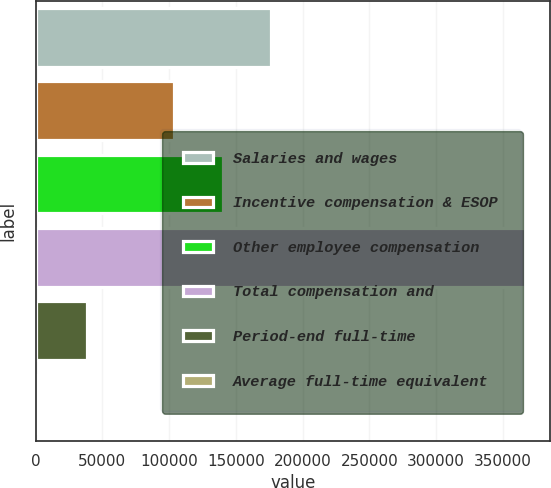<chart> <loc_0><loc_0><loc_500><loc_500><bar_chart><fcel>Salaries and wages<fcel>Incentive compensation & ESOP<fcel>Other employee compensation<fcel>Total compensation and<fcel>Period-end full-time<fcel>Average full-time equivalent<nl><fcel>176520<fcel>103494<fcel>140007<fcel>366801<fcel>38182.2<fcel>1669<nl></chart> 